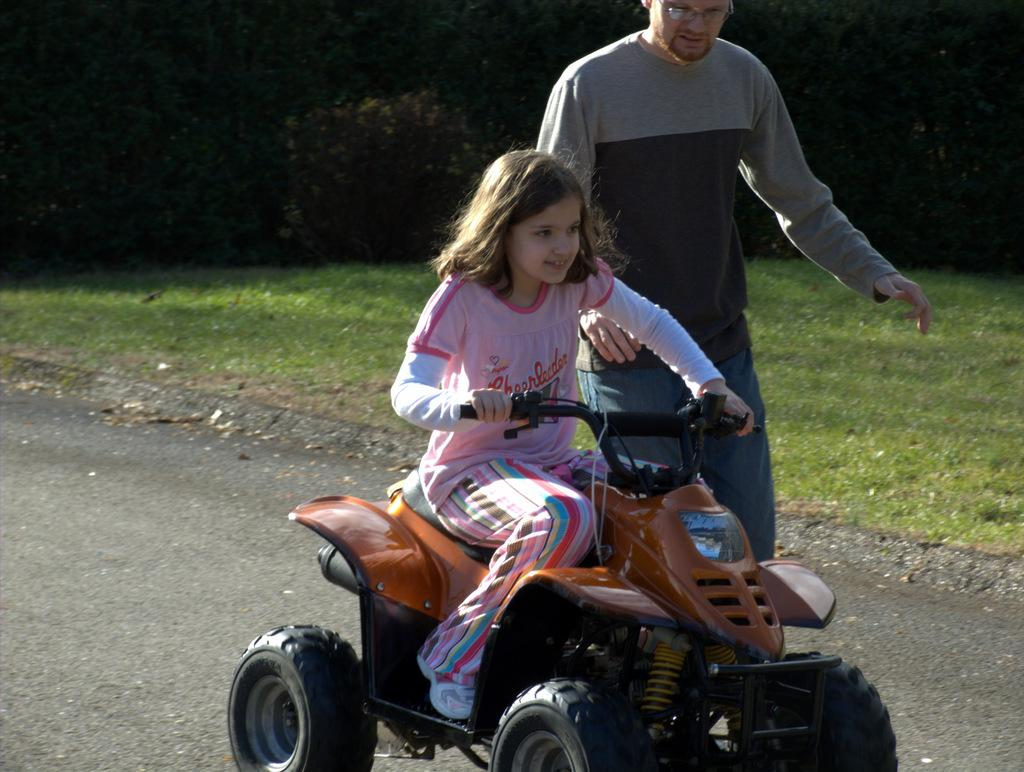What is the main subject of the image? The main subject of the image is a man. Can you describe the man's appearance? The man is wearing spectacles. Who else is present in the image? There is a girl in the image. What is the girl doing in the image? The girl is riding a bike on the road. What type of environment can be seen in the image? There is grass visible in the image, and trees are in the background. What is the reaction of the porter to the man's wing in the image? There is no porter or wing present in the image. What type of wing can be seen on the man in the image? There is no wing visible on the man in the image. 